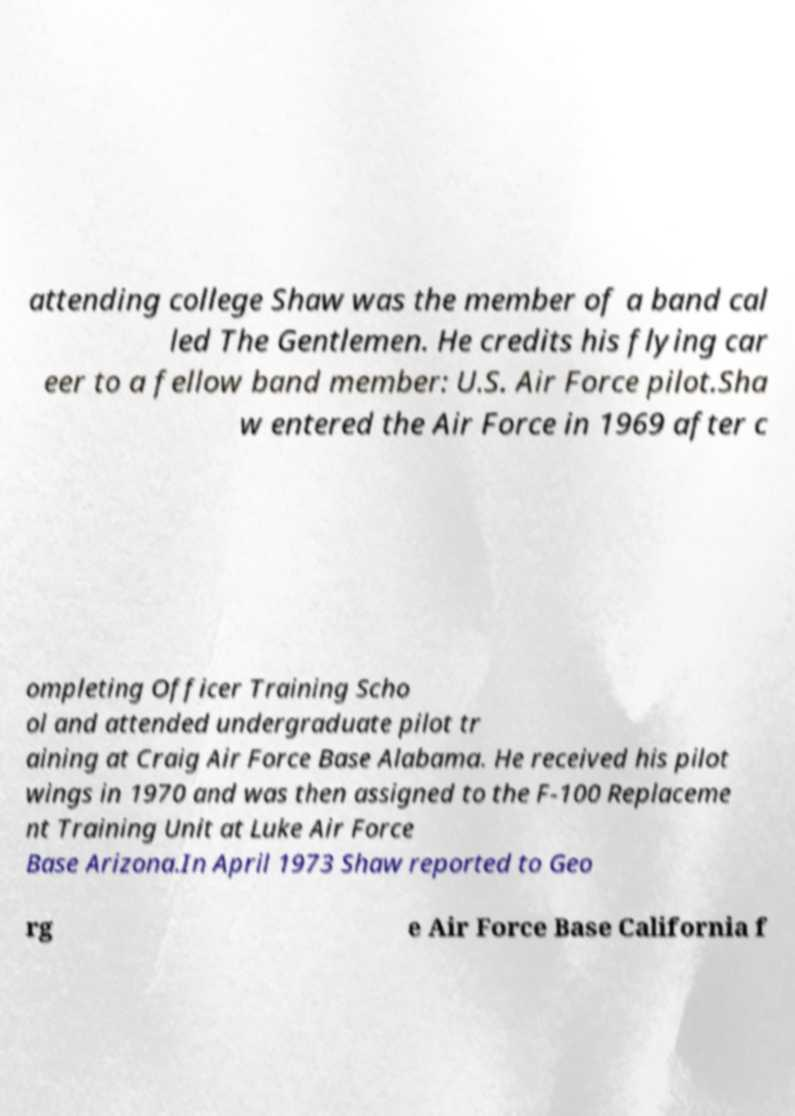Can you read and provide the text displayed in the image?This photo seems to have some interesting text. Can you extract and type it out for me? attending college Shaw was the member of a band cal led The Gentlemen. He credits his flying car eer to a fellow band member: U.S. Air Force pilot.Sha w entered the Air Force in 1969 after c ompleting Officer Training Scho ol and attended undergraduate pilot tr aining at Craig Air Force Base Alabama. He received his pilot wings in 1970 and was then assigned to the F-100 Replaceme nt Training Unit at Luke Air Force Base Arizona.In April 1973 Shaw reported to Geo rg e Air Force Base California f 